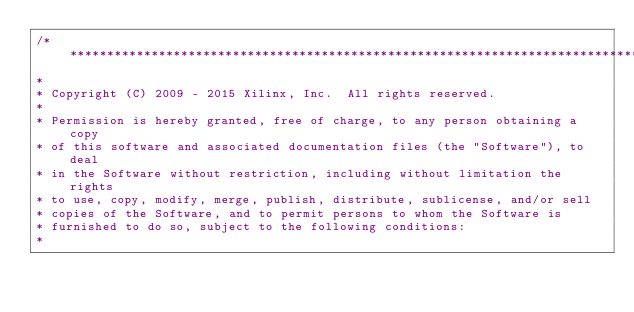<code> <loc_0><loc_0><loc_500><loc_500><_C_>/******************************************************************************
*
* Copyright (C) 2009 - 2015 Xilinx, Inc.  All rights reserved.
*
* Permission is hereby granted, free of charge, to any person obtaining a copy
* of this software and associated documentation files (the "Software"), to deal
* in the Software without restriction, including without limitation the rights
* to use, copy, modify, merge, publish, distribute, sublicense, and/or sell
* copies of the Software, and to permit persons to whom the Software is
* furnished to do so, subject to the following conditions:
*</code> 